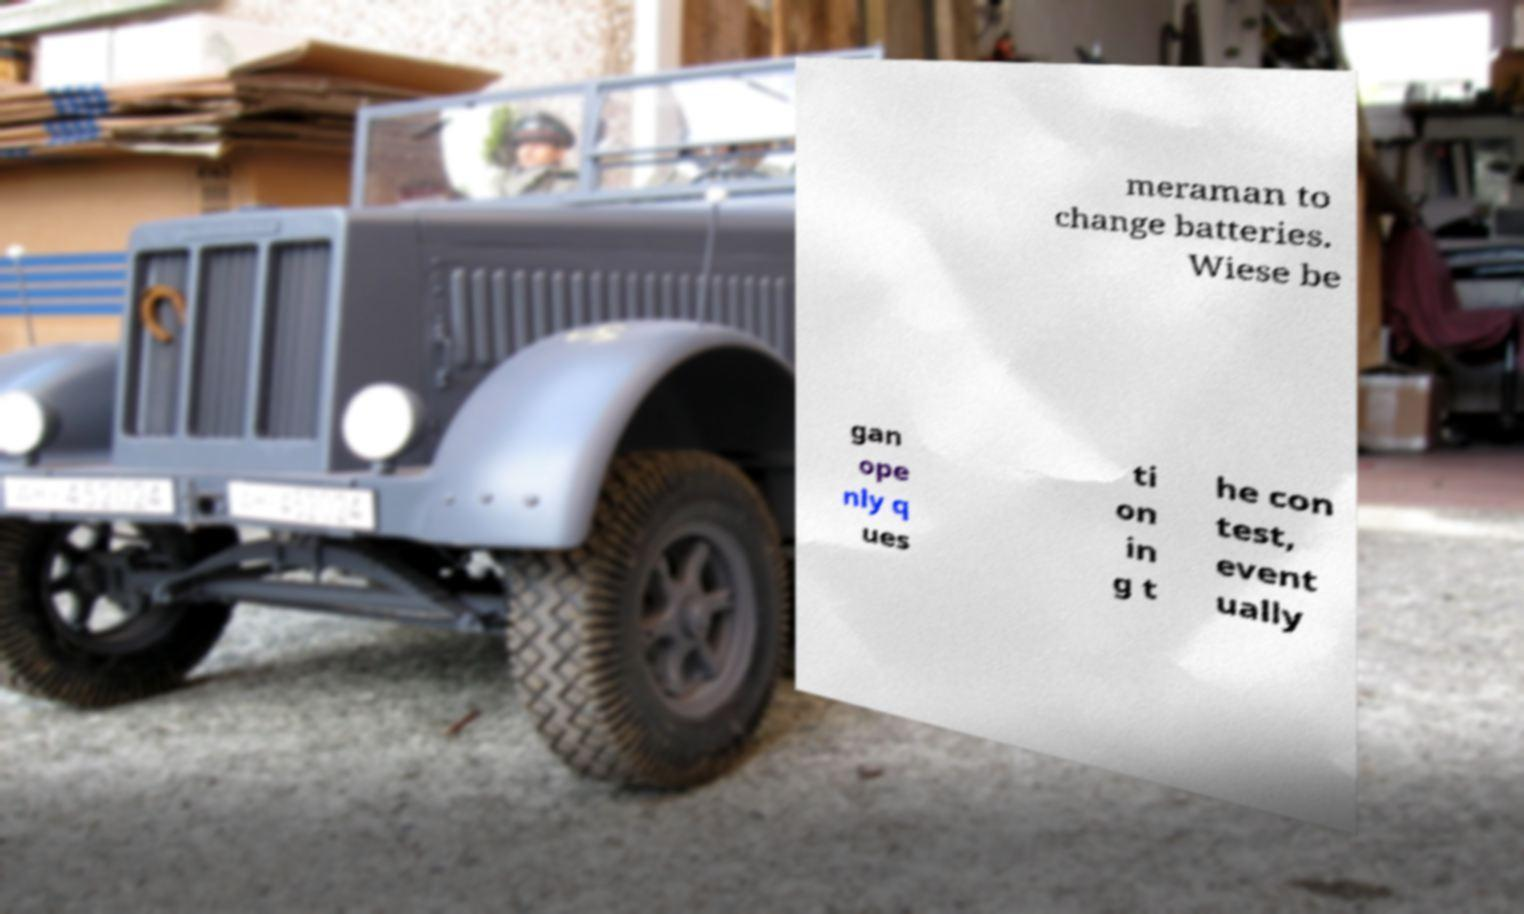There's text embedded in this image that I need extracted. Can you transcribe it verbatim? meraman to change batteries. Wiese be gan ope nly q ues ti on in g t he con test, event ually 